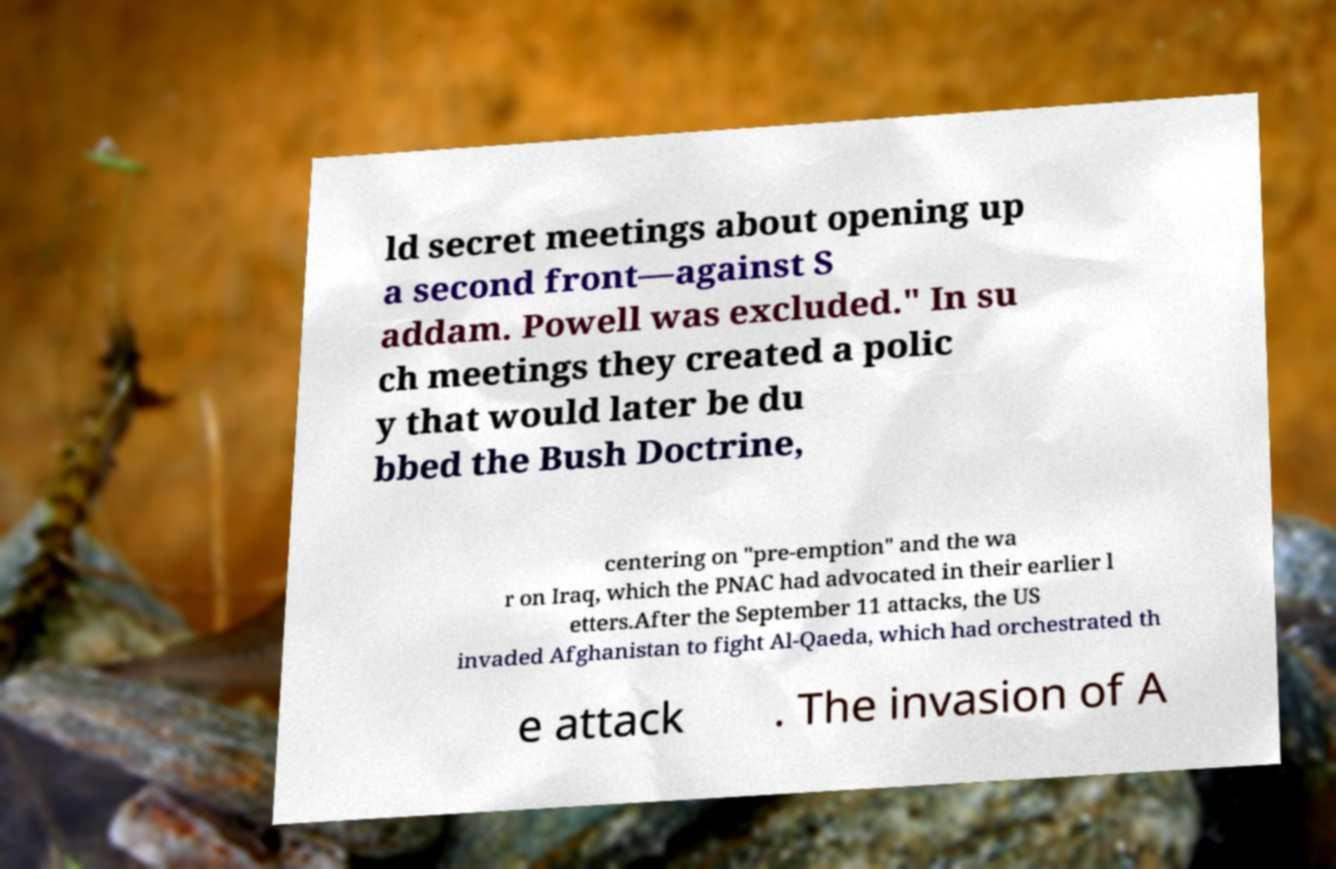What messages or text are displayed in this image? I need them in a readable, typed format. ld secret meetings about opening up a second front—against S addam. Powell was excluded." In su ch meetings they created a polic y that would later be du bbed the Bush Doctrine, centering on "pre-emption" and the wa r on Iraq, which the PNAC had advocated in their earlier l etters.After the September 11 attacks, the US invaded Afghanistan to fight Al-Qaeda, which had orchestrated th e attack . The invasion of A 